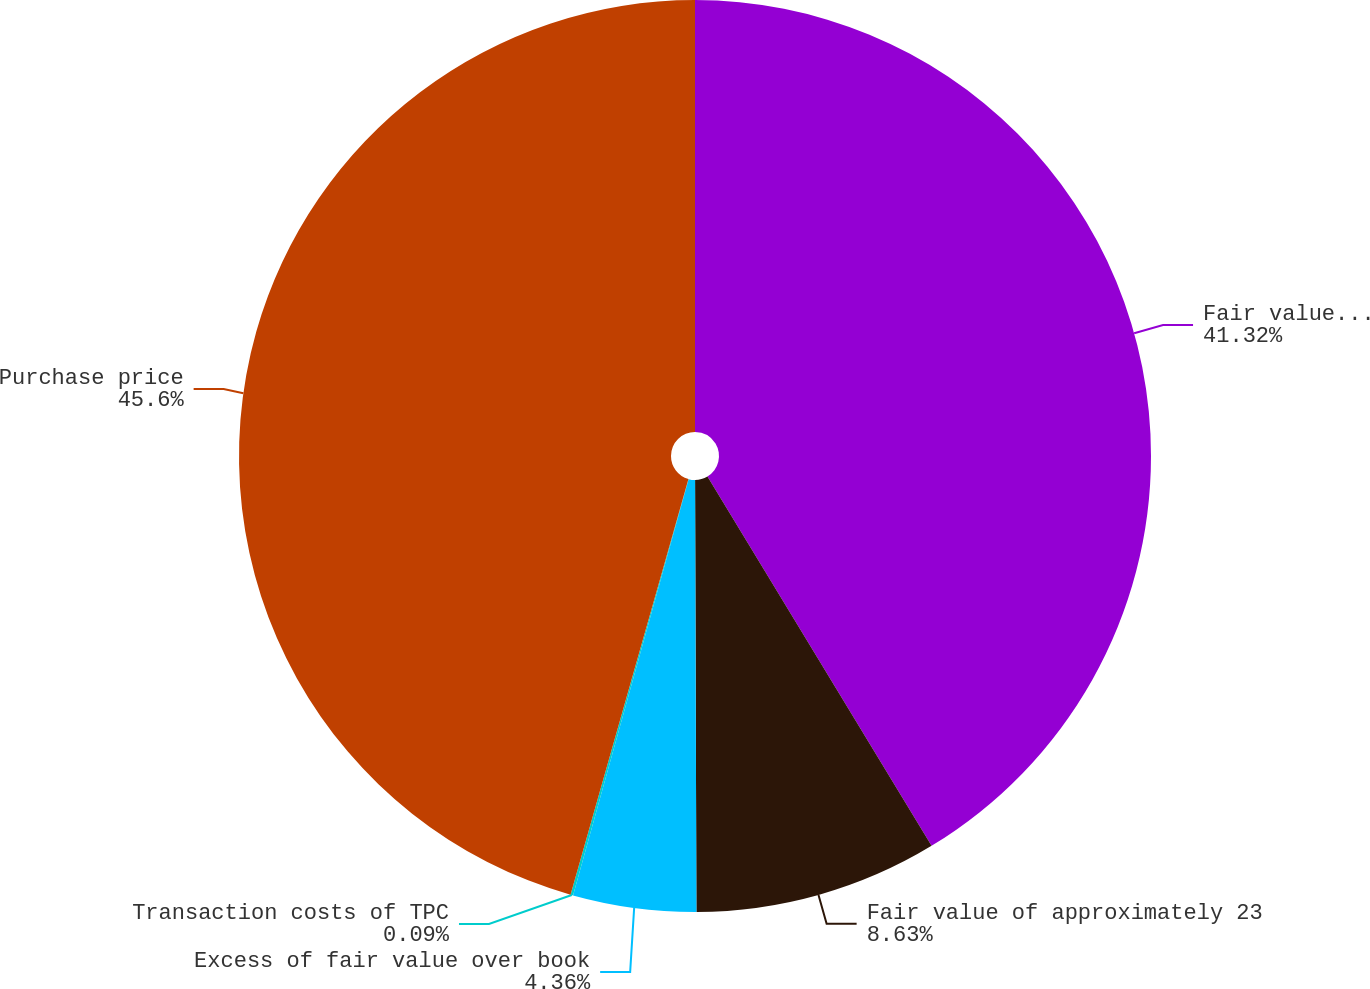<chart> <loc_0><loc_0><loc_500><loc_500><pie_chart><fcel>Fair value of SPC's common<fcel>Fair value of approximately 23<fcel>Excess of fair value over book<fcel>Transaction costs of TPC<fcel>Purchase price<nl><fcel>41.32%<fcel>8.63%<fcel>4.36%<fcel>0.09%<fcel>45.6%<nl></chart> 